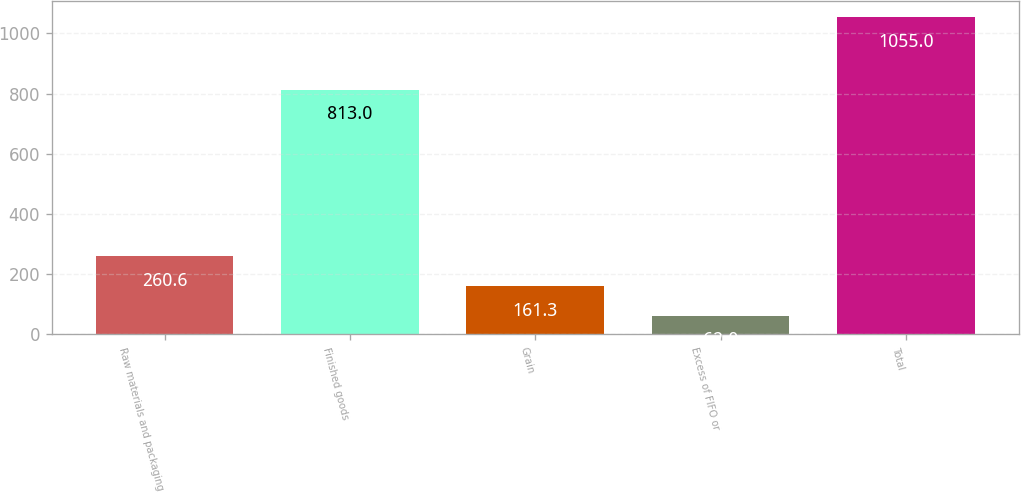Convert chart to OTSL. <chart><loc_0><loc_0><loc_500><loc_500><bar_chart><fcel>Raw materials and packaging<fcel>Finished goods<fcel>Grain<fcel>Excess of FIFO or<fcel>Total<nl><fcel>260.6<fcel>813<fcel>161.3<fcel>62<fcel>1055<nl></chart> 